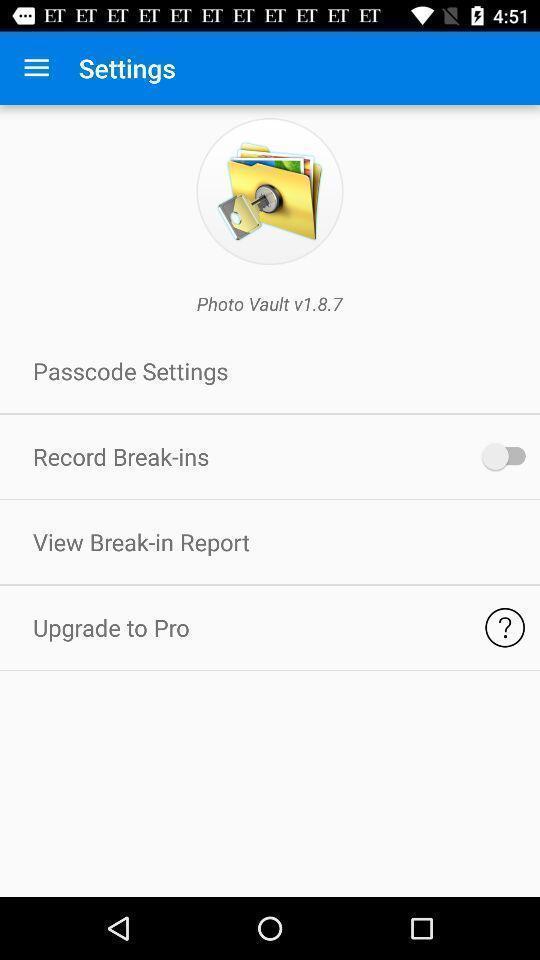Summarize the information in this screenshot. Settings page for the photo storage app. 